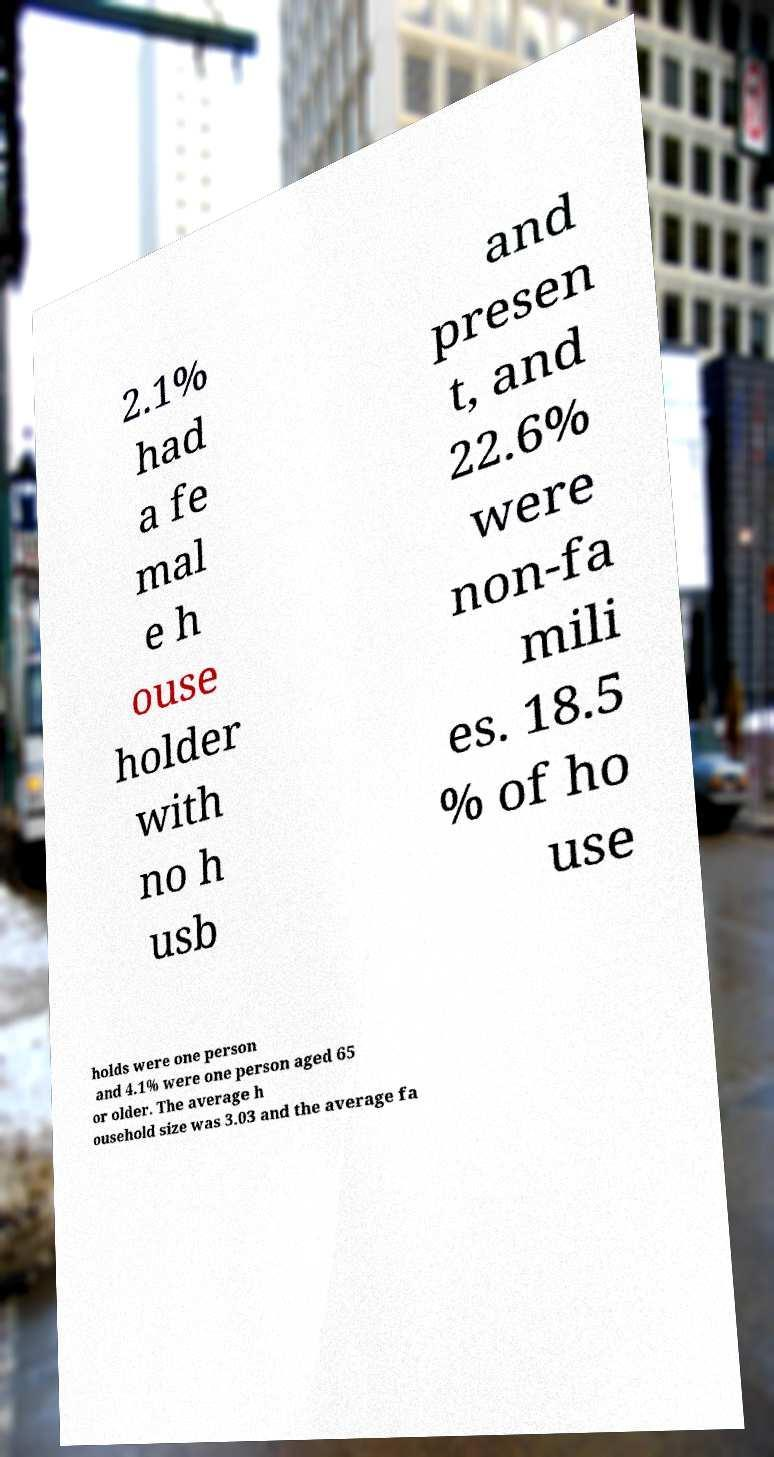For documentation purposes, I need the text within this image transcribed. Could you provide that? 2.1% had a fe mal e h ouse holder with no h usb and presen t, and 22.6% were non-fa mili es. 18.5 % of ho use holds were one person and 4.1% were one person aged 65 or older. The average h ousehold size was 3.03 and the average fa 